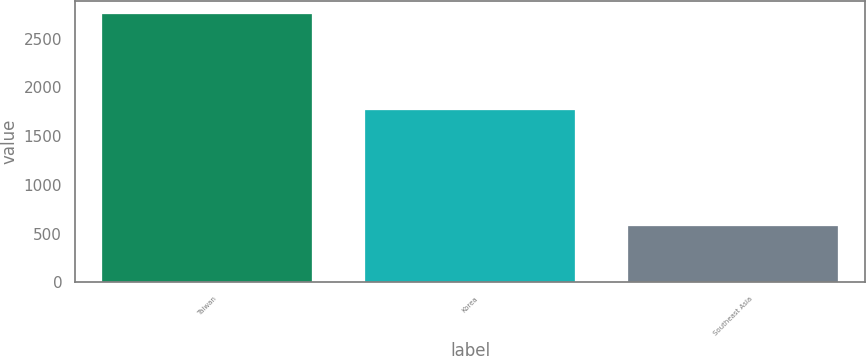<chart> <loc_0><loc_0><loc_500><loc_500><bar_chart><fcel>Taiwan<fcel>Korea<fcel>Southeast Asia<nl><fcel>2750<fcel>1768<fcel>578<nl></chart> 